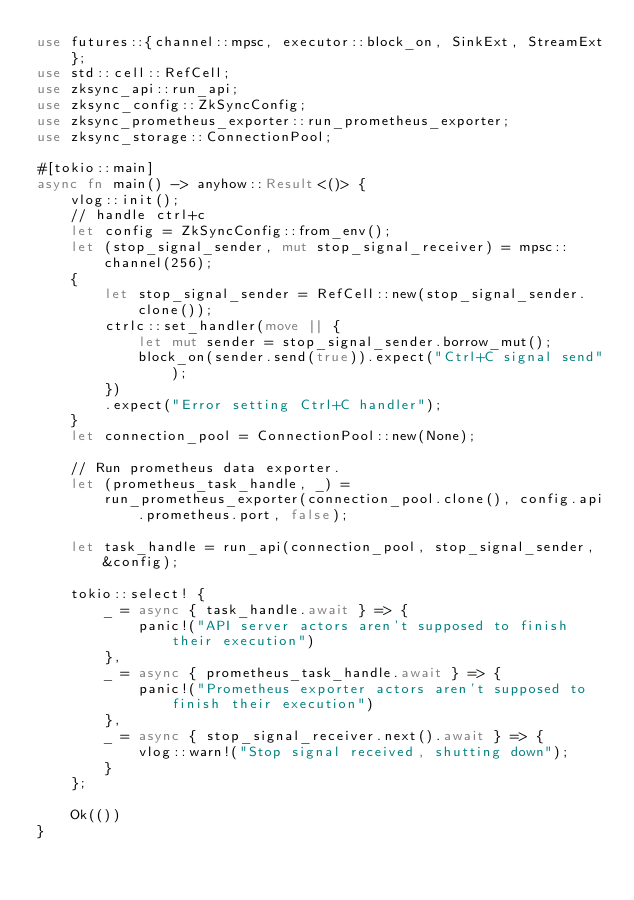Convert code to text. <code><loc_0><loc_0><loc_500><loc_500><_Rust_>use futures::{channel::mpsc, executor::block_on, SinkExt, StreamExt};
use std::cell::RefCell;
use zksync_api::run_api;
use zksync_config::ZkSyncConfig;
use zksync_prometheus_exporter::run_prometheus_exporter;
use zksync_storage::ConnectionPool;

#[tokio::main]
async fn main() -> anyhow::Result<()> {
    vlog::init();
    // handle ctrl+c
    let config = ZkSyncConfig::from_env();
    let (stop_signal_sender, mut stop_signal_receiver) = mpsc::channel(256);
    {
        let stop_signal_sender = RefCell::new(stop_signal_sender.clone());
        ctrlc::set_handler(move || {
            let mut sender = stop_signal_sender.borrow_mut();
            block_on(sender.send(true)).expect("Ctrl+C signal send");
        })
        .expect("Error setting Ctrl+C handler");
    }
    let connection_pool = ConnectionPool::new(None);

    // Run prometheus data exporter.
    let (prometheus_task_handle, _) =
        run_prometheus_exporter(connection_pool.clone(), config.api.prometheus.port, false);

    let task_handle = run_api(connection_pool, stop_signal_sender, &config);

    tokio::select! {
        _ = async { task_handle.await } => {
            panic!("API server actors aren't supposed to finish their execution")
        },
        _ = async { prometheus_task_handle.await } => {
            panic!("Prometheus exporter actors aren't supposed to finish their execution")
        },
        _ = async { stop_signal_receiver.next().await } => {
            vlog::warn!("Stop signal received, shutting down");
        }
    };

    Ok(())
}
</code> 